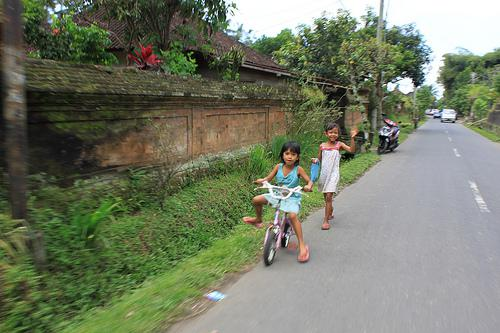Question: how many children?
Choices:
A. One.
B. Three.
C. Five.
D. Two.
Answer with the letter. Answer: D Question: who is in the picture?
Choices:
A. 2 kids.
B. Two girls.
C. 2 people.
D. 2 youth.
Answer with the letter. Answer: B Question: where are the girls?
Choices:
A. Next to the road.
B. On the side of the road.
C. By the road.
D. Next to where cars drive.
Answer with the letter. Answer: B Question: what is the girl with the dress doing?
Choices:
A. Waving.
B. Holding up her arm.
C. Getting someone's attention.
D. Saying hello.
Answer with the letter. Answer: A Question: who is riding the bike?
Choices:
A. The girl.
B. The child.
C. The kid.
D. The young person.
Answer with the letter. Answer: A Question: what is the two wheeler the girl is on?
Choices:
A. A bike.
B. A bicycle.
C. A toy.
D. A riding aparatace.
Answer with the letter. Answer: A Question: where is the picture taken?
Choices:
A. Sidewalk.
B. Park.
C. On the road.
D. Ocean.
Answer with the letter. Answer: C 